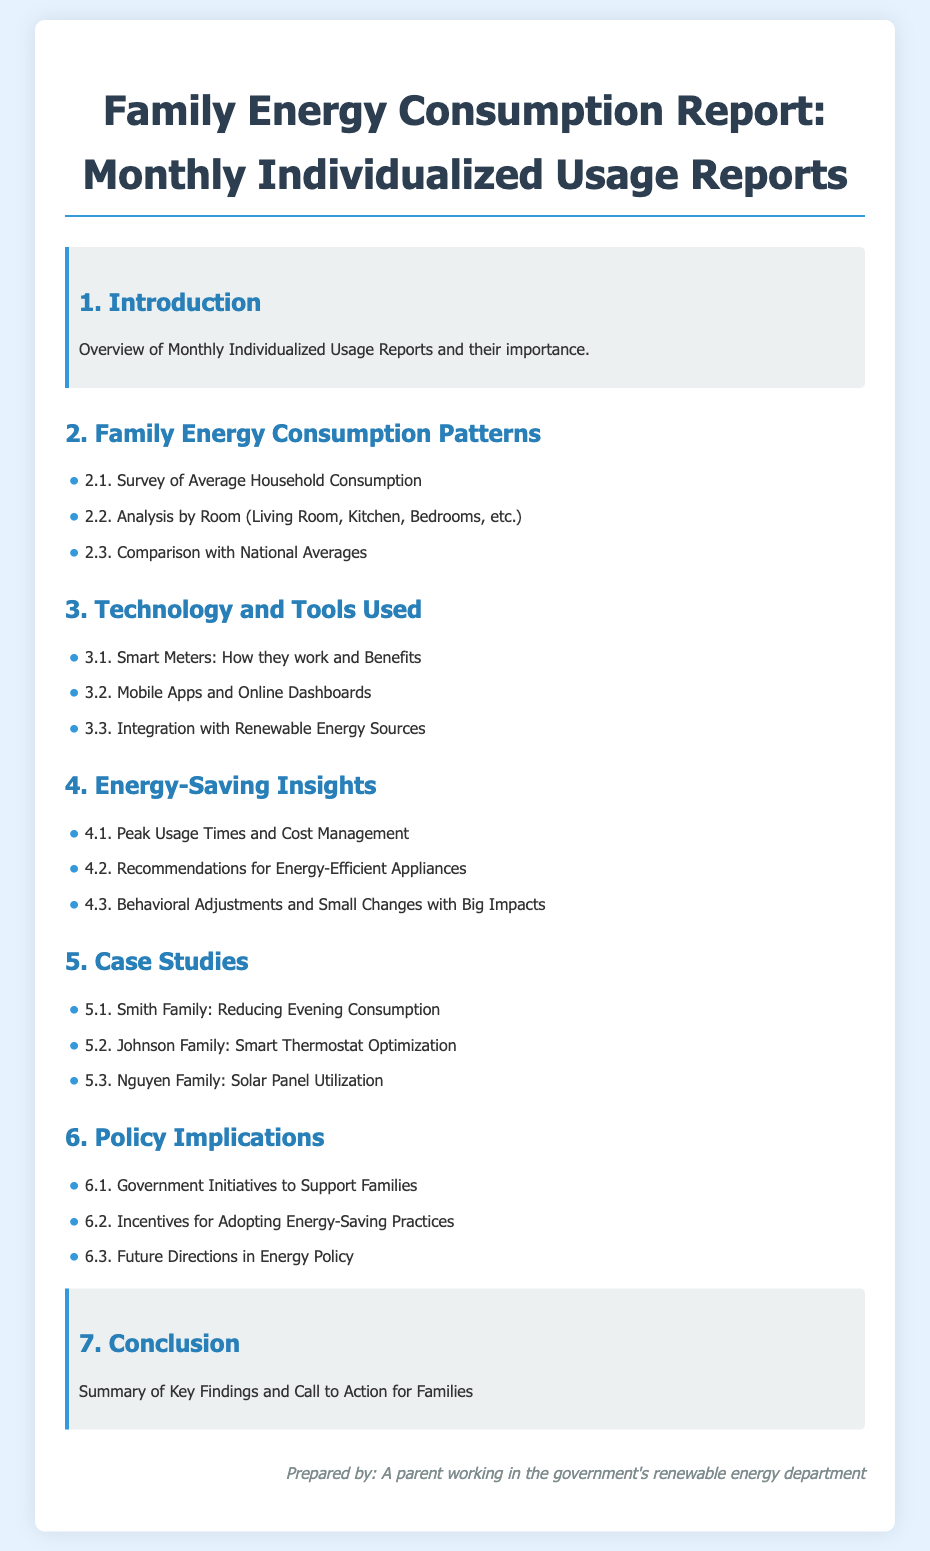What is the title of the document? The title is presented at the top of the document in an emphasized manner.
Answer: Family Energy Consumption Report: Monthly Individualized Usage Reports How many sections are there in the report? The main sections are numbered and presented under the headings in the document.
Answer: 7 What is discussed in section 2.2? Section 2.2 is specifically focused on a particular aspect of energy consumption within the home.
Answer: Analysis by Room (Living Room, Kitchen, Bedrooms, etc.) What technology is highlighted in section 3.1? Section 3.1 mentions a specific type of technology related to energy consumption monitoring.
Answer: Smart Meters Which family is associated with solar panel utilization? This family is noted in the case studies section of the report.
Answer: Nguyen Family What does section 6.2 discuss? Section 6.2 provides insights on incentives related to energy-saving practices.
Answer: Incentives for Adopting Energy-Saving Practices What is the primary focus of section 4? The section describes strategies and recommendations for reducing energy consumption.
Answer: Energy-Saving Insights What is the purpose of the conclusion? The conclusion summarizes key insights and encourages specific actions.
Answer: Summary of Key Findings and Call to Action for Families 